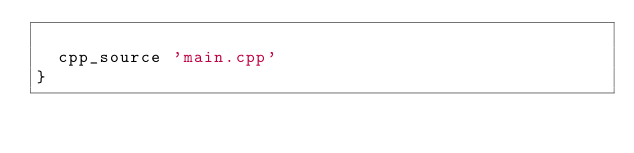Convert code to text. <code><loc_0><loc_0><loc_500><loc_500><_Ruby_>
	cpp_source 'main.cpp'
}

</code> 